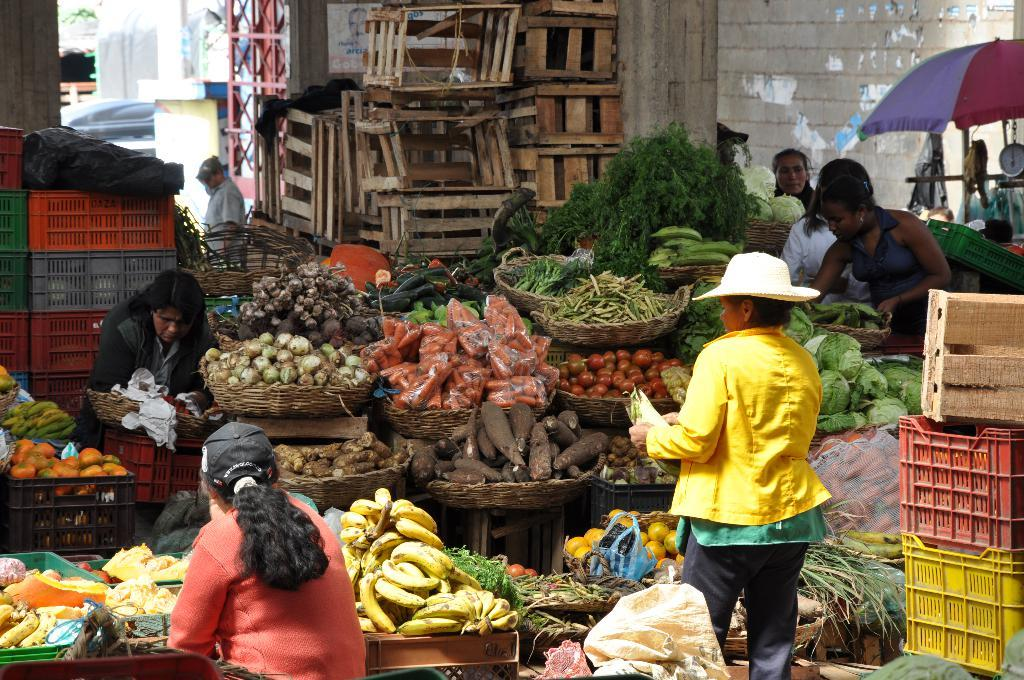What type of structure can be seen in the image? There is a wall in the image. What objects are present in the image that might be used for storage? There are boxes in the image. What type of food items can be seen in the image? There are vegetables in the image. What type of vegetation is visible in the image? There are trees in the image. What objects are present in the image that might be used for carrying items? There are baskets in the image. Who is present in the image? There are people in the image. What object is present in the image that might be used for protection from the sun or rain? There is an umbrella in the image. What type of man-made structures can be seen in the image? There are buildings in the image. What is the tendency of the vegetables to grow in the image? The image does not provide information about the growth tendency of the vegetables. Can the vegetables in the image be used to make a can of soup? The image does not provide information about the specific type of vegetables or their usability for making soup. What is the taste of the umbrella in the image? Umbrellas do not have a taste, as they are not edible objects. 